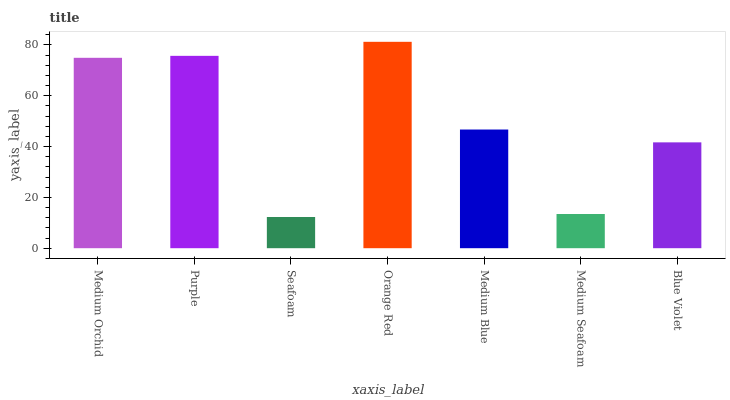Is Seafoam the minimum?
Answer yes or no. Yes. Is Orange Red the maximum?
Answer yes or no. Yes. Is Purple the minimum?
Answer yes or no. No. Is Purple the maximum?
Answer yes or no. No. Is Purple greater than Medium Orchid?
Answer yes or no. Yes. Is Medium Orchid less than Purple?
Answer yes or no. Yes. Is Medium Orchid greater than Purple?
Answer yes or no. No. Is Purple less than Medium Orchid?
Answer yes or no. No. Is Medium Blue the high median?
Answer yes or no. Yes. Is Medium Blue the low median?
Answer yes or no. Yes. Is Orange Red the high median?
Answer yes or no. No. Is Medium Seafoam the low median?
Answer yes or no. No. 